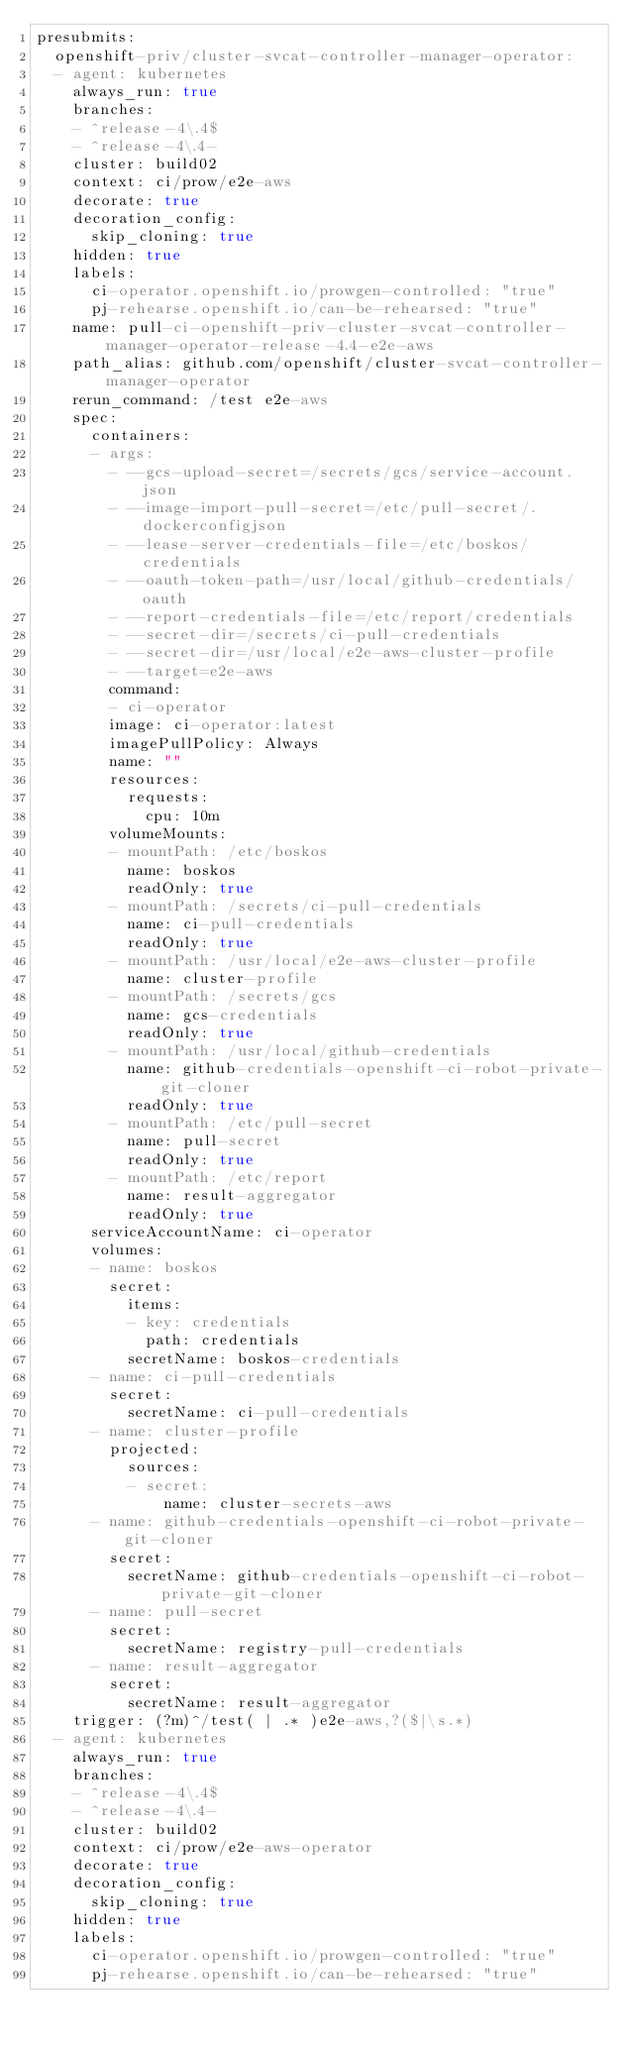<code> <loc_0><loc_0><loc_500><loc_500><_YAML_>presubmits:
  openshift-priv/cluster-svcat-controller-manager-operator:
  - agent: kubernetes
    always_run: true
    branches:
    - ^release-4\.4$
    - ^release-4\.4-
    cluster: build02
    context: ci/prow/e2e-aws
    decorate: true
    decoration_config:
      skip_cloning: true
    hidden: true
    labels:
      ci-operator.openshift.io/prowgen-controlled: "true"
      pj-rehearse.openshift.io/can-be-rehearsed: "true"
    name: pull-ci-openshift-priv-cluster-svcat-controller-manager-operator-release-4.4-e2e-aws
    path_alias: github.com/openshift/cluster-svcat-controller-manager-operator
    rerun_command: /test e2e-aws
    spec:
      containers:
      - args:
        - --gcs-upload-secret=/secrets/gcs/service-account.json
        - --image-import-pull-secret=/etc/pull-secret/.dockerconfigjson
        - --lease-server-credentials-file=/etc/boskos/credentials
        - --oauth-token-path=/usr/local/github-credentials/oauth
        - --report-credentials-file=/etc/report/credentials
        - --secret-dir=/secrets/ci-pull-credentials
        - --secret-dir=/usr/local/e2e-aws-cluster-profile
        - --target=e2e-aws
        command:
        - ci-operator
        image: ci-operator:latest
        imagePullPolicy: Always
        name: ""
        resources:
          requests:
            cpu: 10m
        volumeMounts:
        - mountPath: /etc/boskos
          name: boskos
          readOnly: true
        - mountPath: /secrets/ci-pull-credentials
          name: ci-pull-credentials
          readOnly: true
        - mountPath: /usr/local/e2e-aws-cluster-profile
          name: cluster-profile
        - mountPath: /secrets/gcs
          name: gcs-credentials
          readOnly: true
        - mountPath: /usr/local/github-credentials
          name: github-credentials-openshift-ci-robot-private-git-cloner
          readOnly: true
        - mountPath: /etc/pull-secret
          name: pull-secret
          readOnly: true
        - mountPath: /etc/report
          name: result-aggregator
          readOnly: true
      serviceAccountName: ci-operator
      volumes:
      - name: boskos
        secret:
          items:
          - key: credentials
            path: credentials
          secretName: boskos-credentials
      - name: ci-pull-credentials
        secret:
          secretName: ci-pull-credentials
      - name: cluster-profile
        projected:
          sources:
          - secret:
              name: cluster-secrets-aws
      - name: github-credentials-openshift-ci-robot-private-git-cloner
        secret:
          secretName: github-credentials-openshift-ci-robot-private-git-cloner
      - name: pull-secret
        secret:
          secretName: registry-pull-credentials
      - name: result-aggregator
        secret:
          secretName: result-aggregator
    trigger: (?m)^/test( | .* )e2e-aws,?($|\s.*)
  - agent: kubernetes
    always_run: true
    branches:
    - ^release-4\.4$
    - ^release-4\.4-
    cluster: build02
    context: ci/prow/e2e-aws-operator
    decorate: true
    decoration_config:
      skip_cloning: true
    hidden: true
    labels:
      ci-operator.openshift.io/prowgen-controlled: "true"
      pj-rehearse.openshift.io/can-be-rehearsed: "true"</code> 